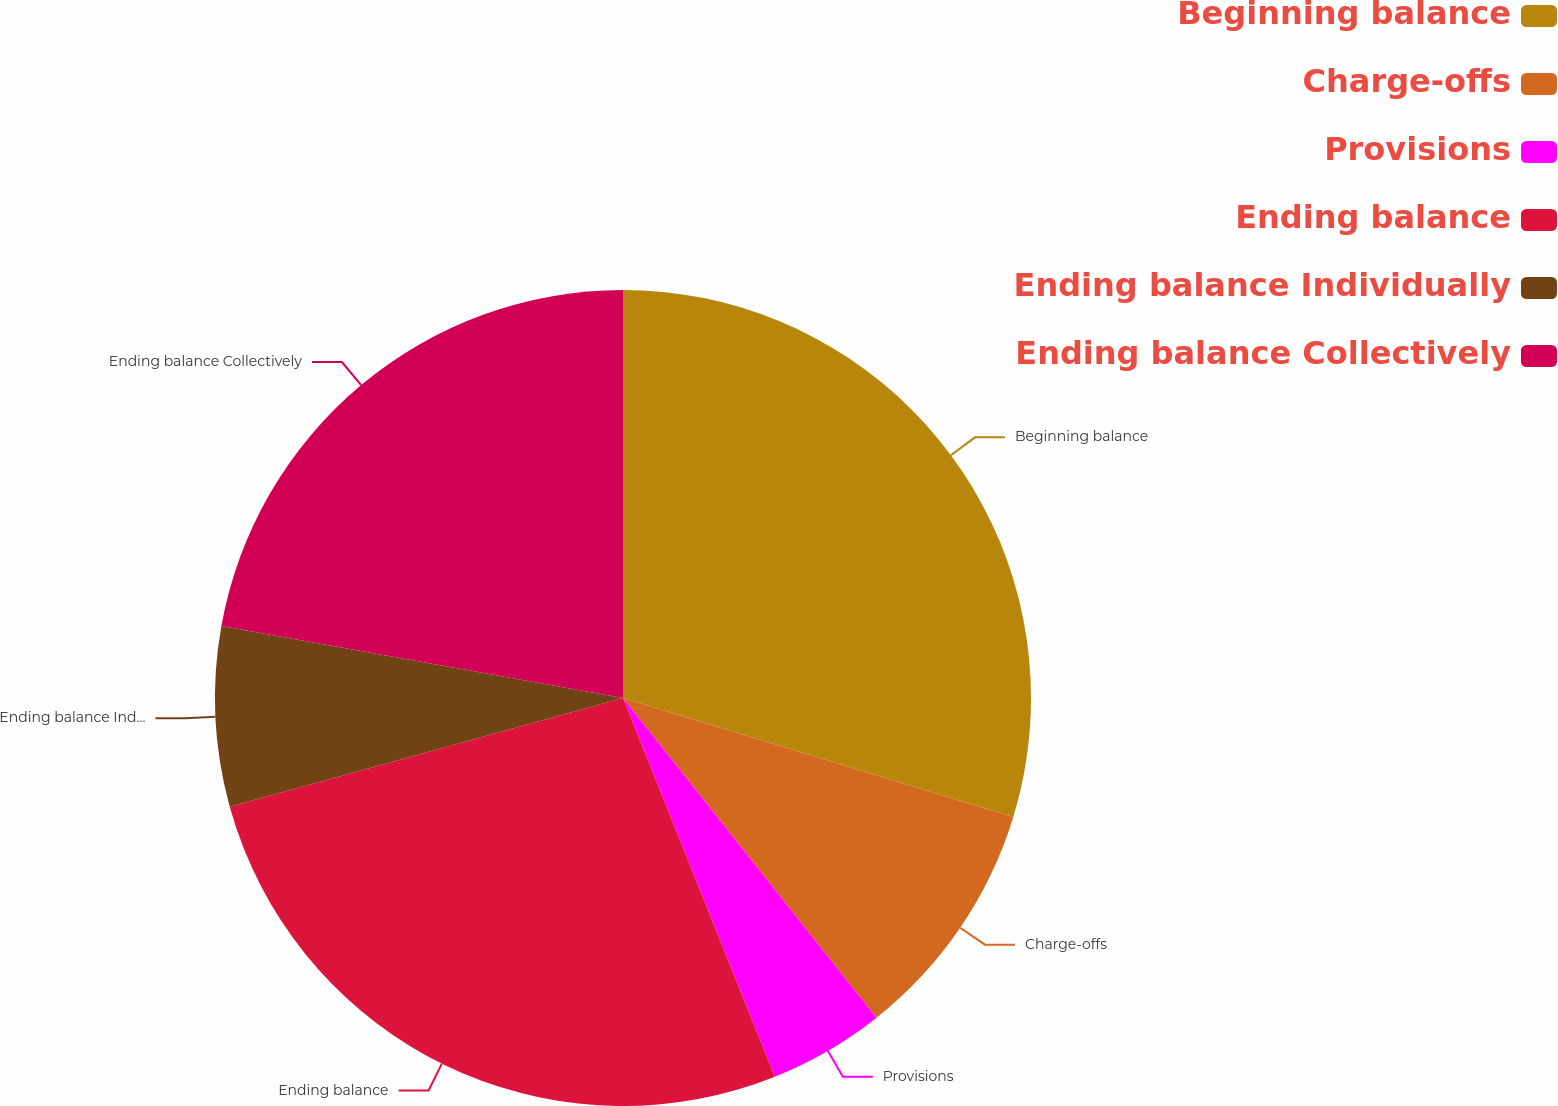<chart> <loc_0><loc_0><loc_500><loc_500><pie_chart><fcel>Beginning balance<fcel>Charge-offs<fcel>Provisions<fcel>Ending balance<fcel>Ending balance Individually<fcel>Ending balance Collectively<nl><fcel>29.71%<fcel>9.62%<fcel>4.6%<fcel>26.78%<fcel>7.11%<fcel>22.18%<nl></chart> 